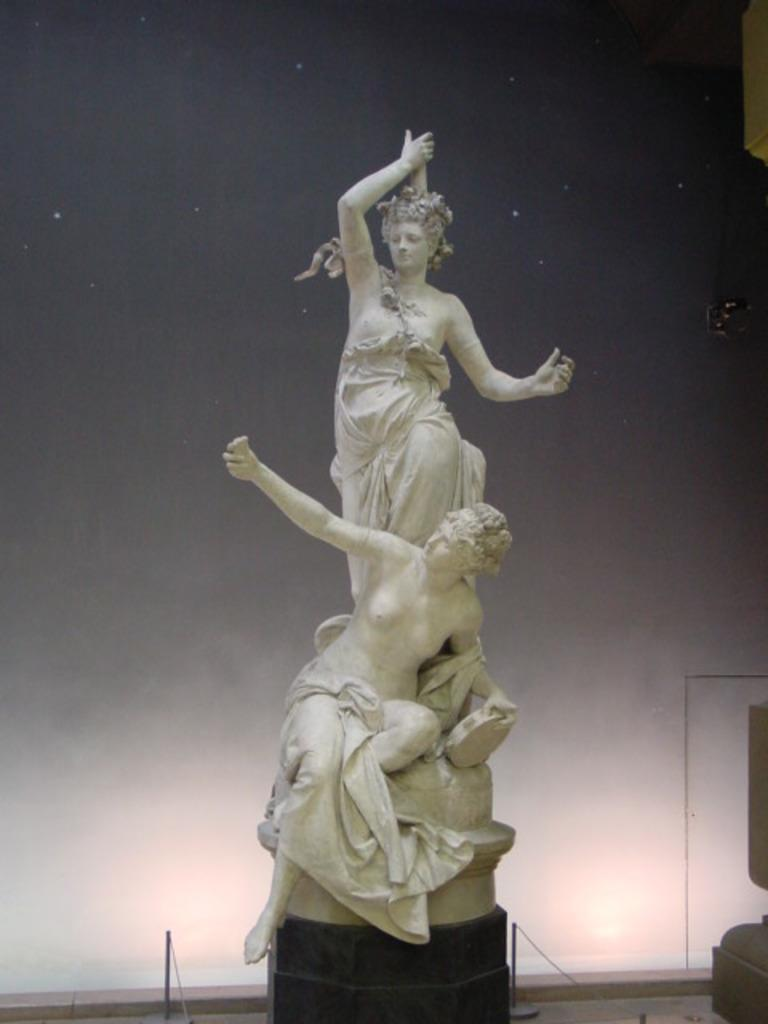What is the main subject of the image? There is a statue in the image. What is the color of the statue? The statue is cream in color. How many persons are depicted in the statue? The statue depicts two persons. What are the actions of the two persons in the statue? One person is staining, and the other person is sitting. What else can be seen in the image besides the statue? There are poles visible in the image, and the sky is visible in the background. What type of scent can be smelled coming from the doll in the image? There is no doll present in the image, so it is not possible to determine any scent associated with it. 